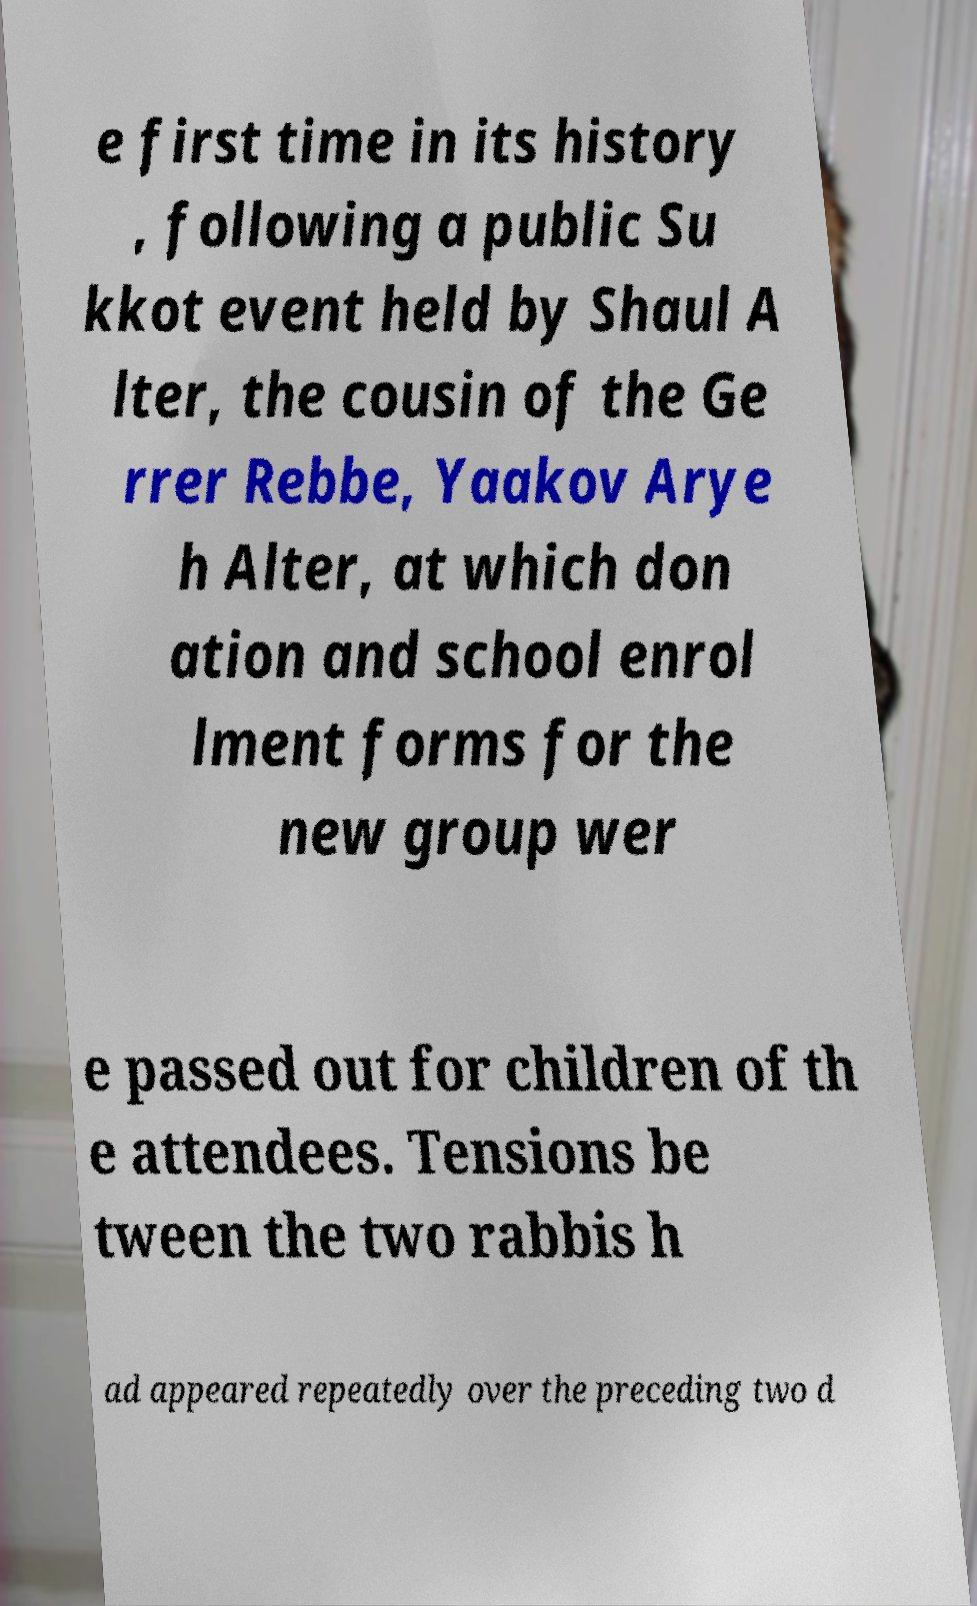Please read and relay the text visible in this image. What does it say? e first time in its history , following a public Su kkot event held by Shaul A lter, the cousin of the Ge rrer Rebbe, Yaakov Arye h Alter, at which don ation and school enrol lment forms for the new group wer e passed out for children of th e attendees. Tensions be tween the two rabbis h ad appeared repeatedly over the preceding two d 